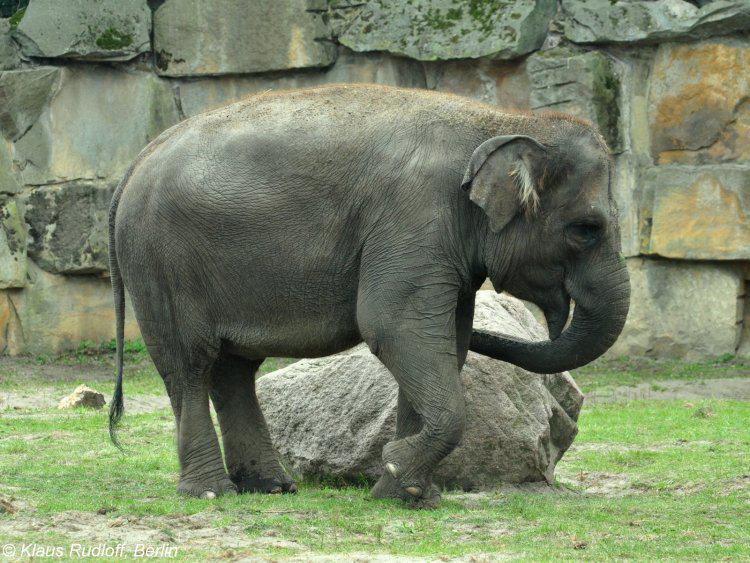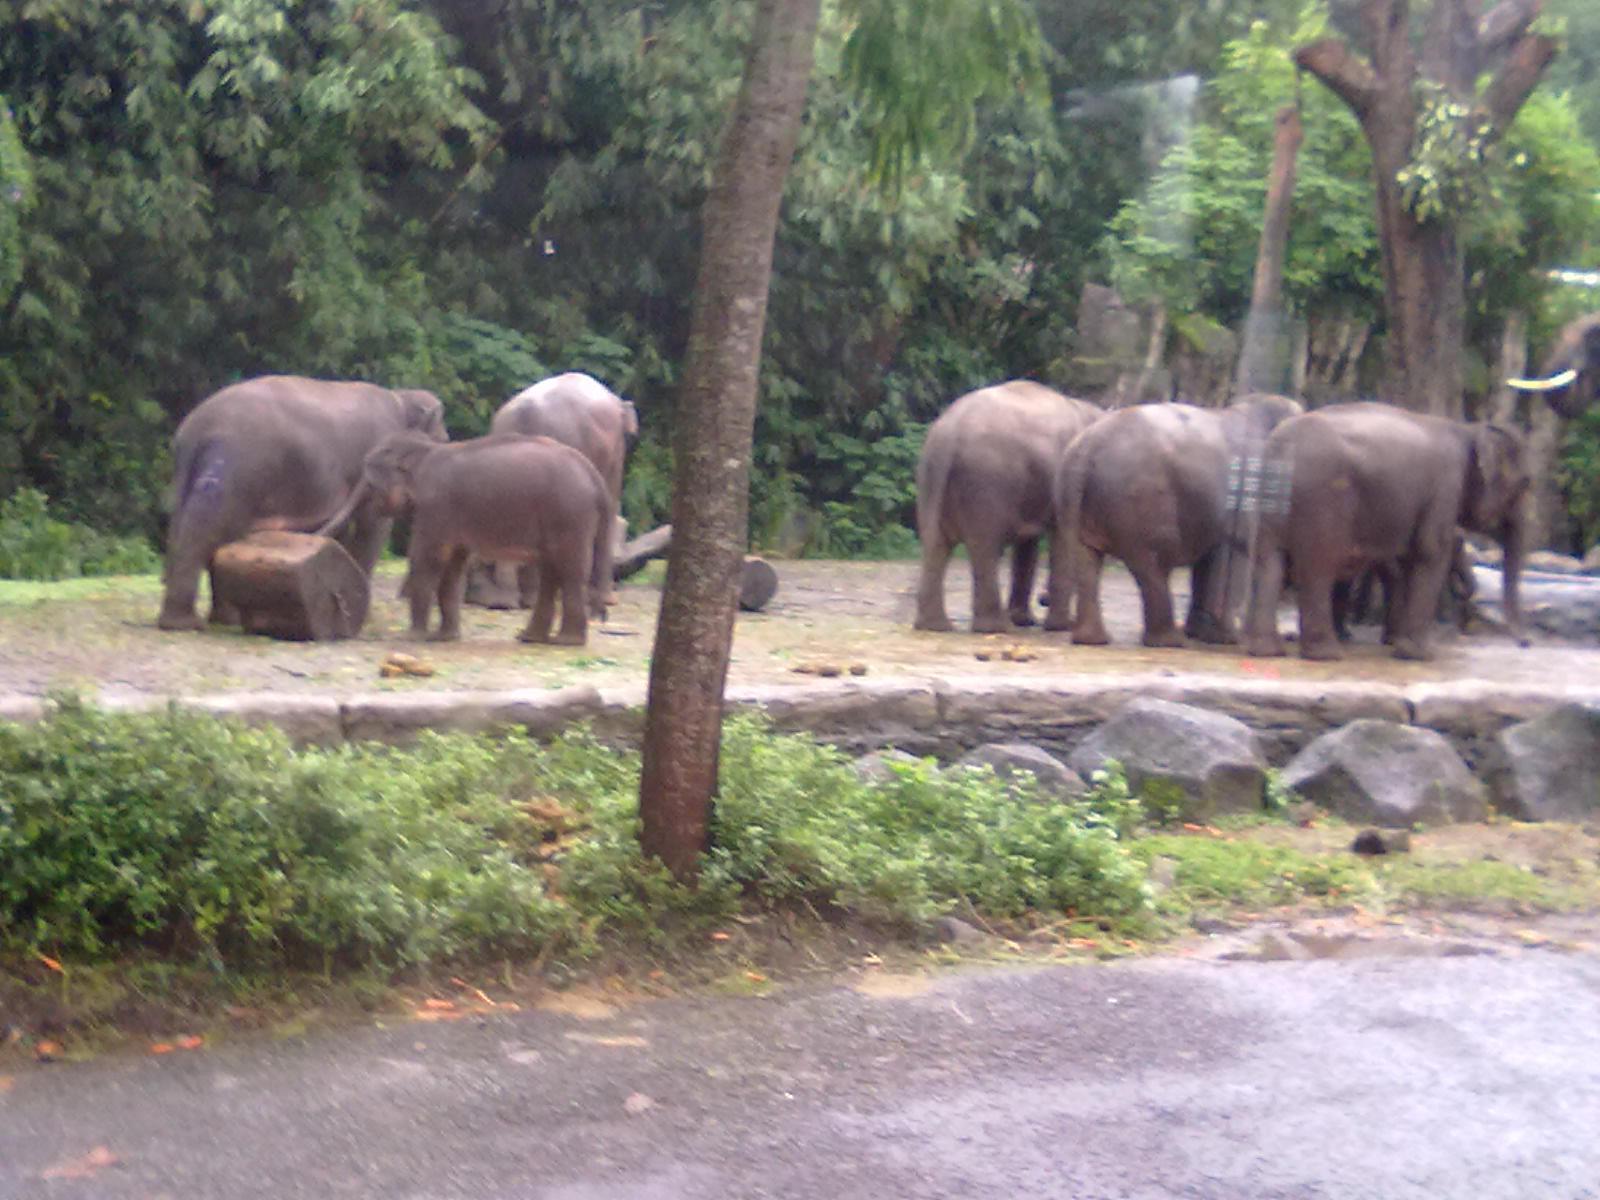The first image is the image on the left, the second image is the image on the right. For the images shown, is this caption "There are at leasts six elephants in one image." true? Answer yes or no. Yes. The first image is the image on the left, the second image is the image on the right. For the images shown, is this caption "there are two elephants in the left side pic" true? Answer yes or no. No. 